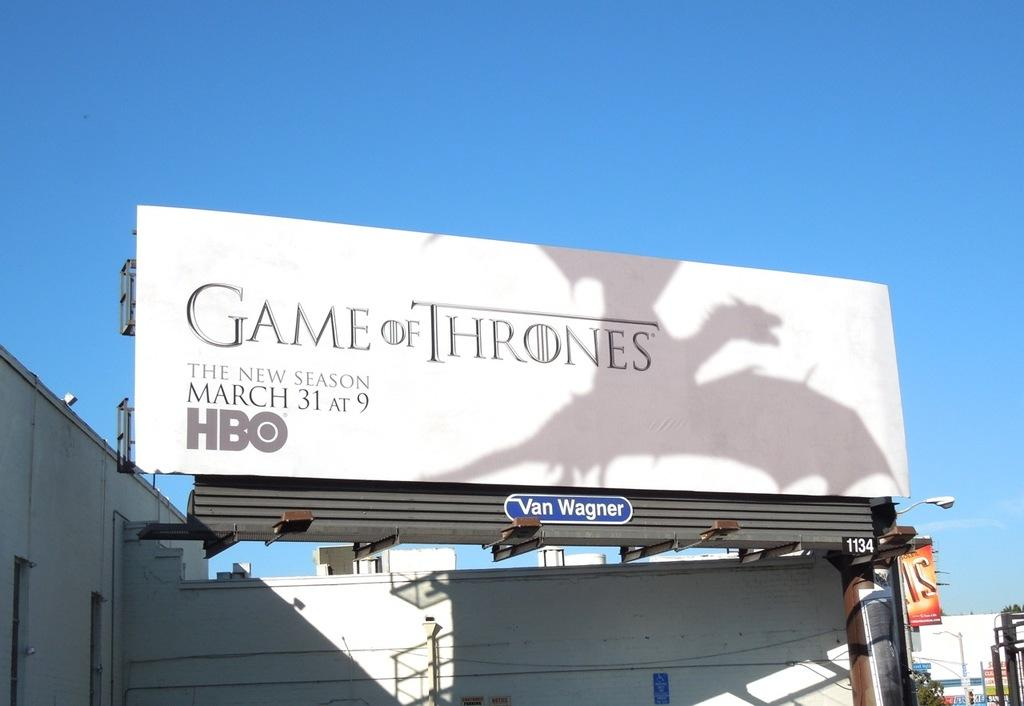<image>
Write a terse but informative summary of the picture. A promotional billboard for the Game of Thrones is white with a dragon on it and tells people that a new season will start March 31 at 9 on HBO. 